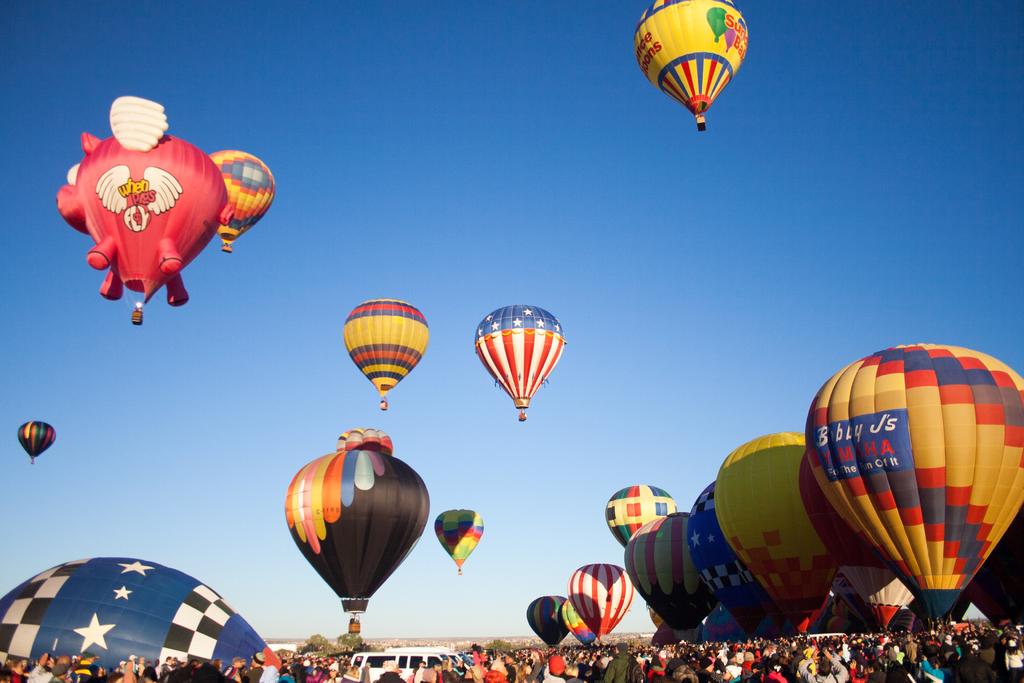What word does one of the hot balloons feature?
Your response must be concise. When. 